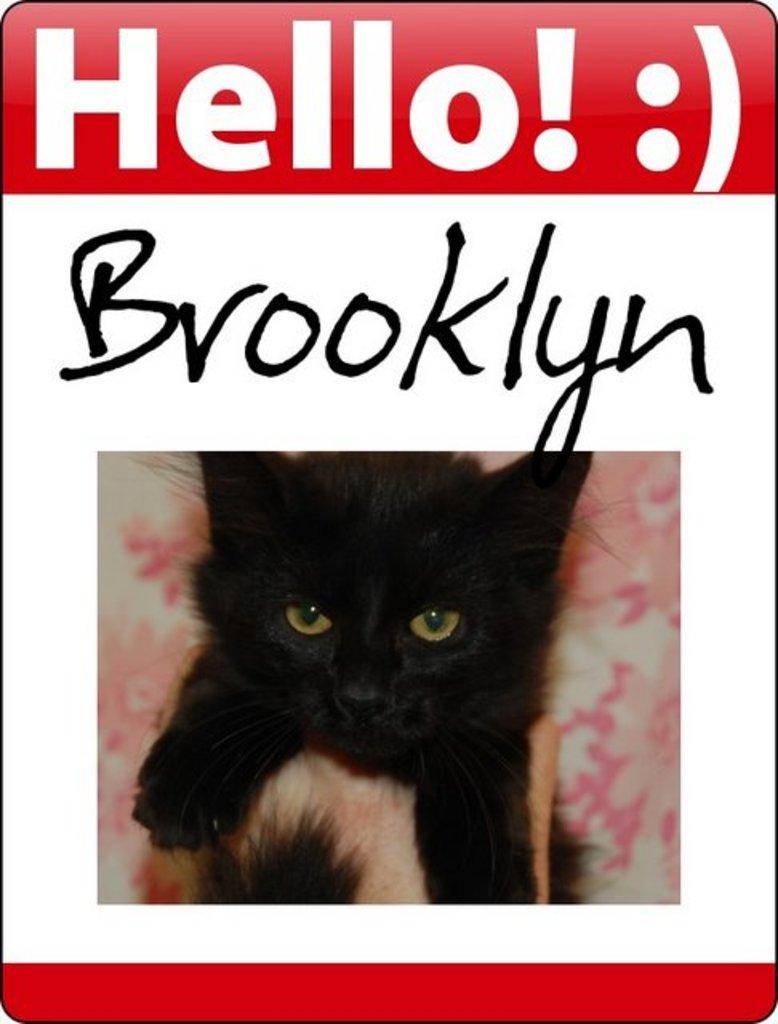What type of animal is in the image? There is a black color cat in the image. What else can be seen in the image besides the cat? There is text in the image. What is the overall appearance of the image? The image appears to be a poster. What color is the background of the image? The background of the image is white. What is the father doing while reading the plant in the image? There is no father, reading, or plant present in the image. 